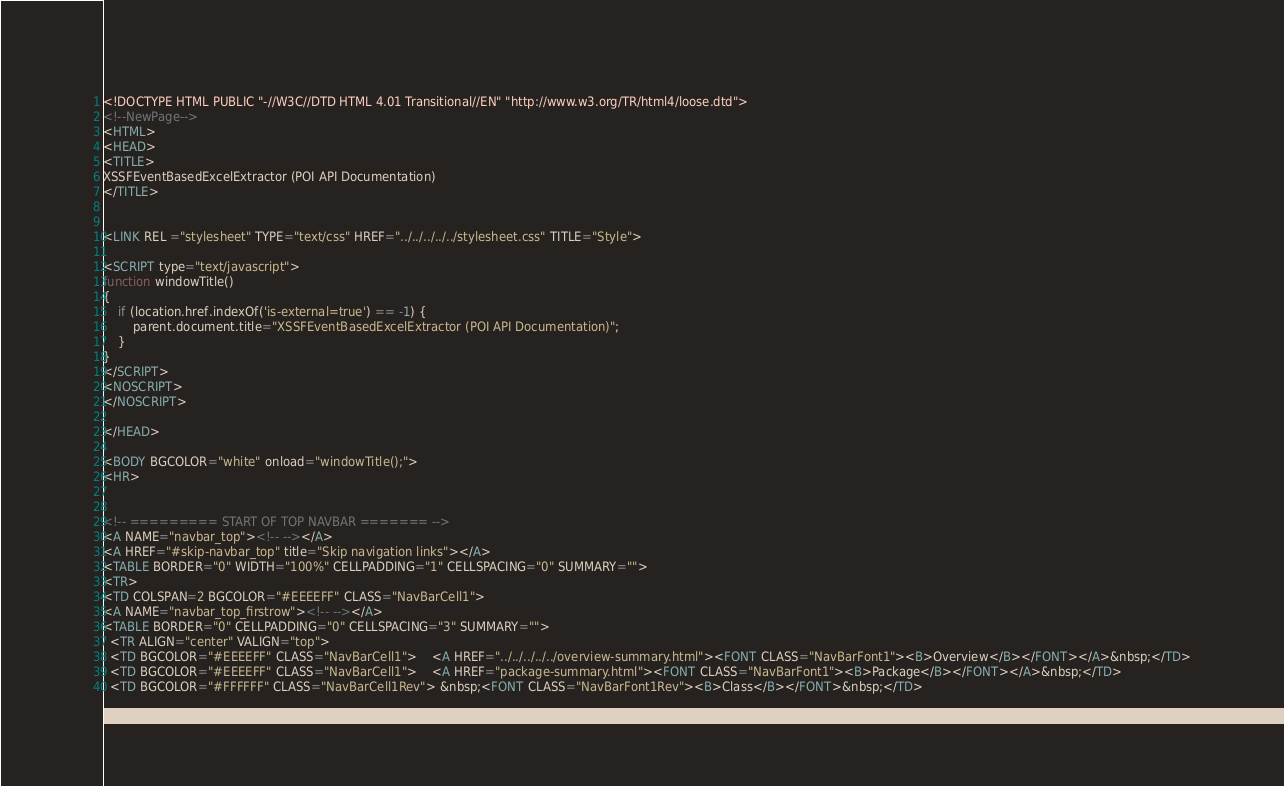<code> <loc_0><loc_0><loc_500><loc_500><_HTML_><!DOCTYPE HTML PUBLIC "-//W3C//DTD HTML 4.01 Transitional//EN" "http://www.w3.org/TR/html4/loose.dtd">
<!--NewPage-->
<HTML>
<HEAD>
<TITLE>
XSSFEventBasedExcelExtractor (POI API Documentation)
</TITLE>


<LINK REL ="stylesheet" TYPE="text/css" HREF="../../../../../stylesheet.css" TITLE="Style">

<SCRIPT type="text/javascript">
function windowTitle()
{
    if (location.href.indexOf('is-external=true') == -1) {
        parent.document.title="XSSFEventBasedExcelExtractor (POI API Documentation)";
    }
}
</SCRIPT>
<NOSCRIPT>
</NOSCRIPT>

</HEAD>

<BODY BGCOLOR="white" onload="windowTitle();">
<HR>


<!-- ========= START OF TOP NAVBAR ======= -->
<A NAME="navbar_top"><!-- --></A>
<A HREF="#skip-navbar_top" title="Skip navigation links"></A>
<TABLE BORDER="0" WIDTH="100%" CELLPADDING="1" CELLSPACING="0" SUMMARY="">
<TR>
<TD COLSPAN=2 BGCOLOR="#EEEEFF" CLASS="NavBarCell1">
<A NAME="navbar_top_firstrow"><!-- --></A>
<TABLE BORDER="0" CELLPADDING="0" CELLSPACING="3" SUMMARY="">
  <TR ALIGN="center" VALIGN="top">
  <TD BGCOLOR="#EEEEFF" CLASS="NavBarCell1">    <A HREF="../../../../../overview-summary.html"><FONT CLASS="NavBarFont1"><B>Overview</B></FONT></A>&nbsp;</TD>
  <TD BGCOLOR="#EEEEFF" CLASS="NavBarCell1">    <A HREF="package-summary.html"><FONT CLASS="NavBarFont1"><B>Package</B></FONT></A>&nbsp;</TD>
  <TD BGCOLOR="#FFFFFF" CLASS="NavBarCell1Rev"> &nbsp;<FONT CLASS="NavBarFont1Rev"><B>Class</B></FONT>&nbsp;</TD></code> 